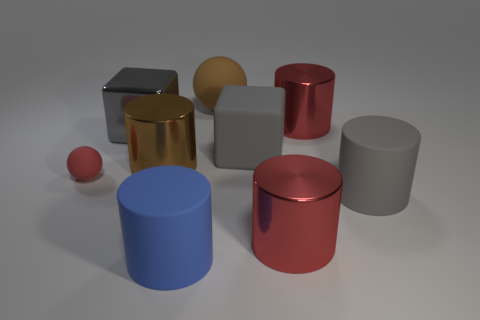Are there any other things that are the same size as the red rubber thing?
Keep it short and to the point. No. There is a object that is to the left of the blue cylinder and in front of the brown cylinder; how big is it?
Your answer should be very brief. Small. There is a large blue object that is the same material as the big ball; what shape is it?
Ensure brevity in your answer.  Cylinder. Is the large blue cylinder made of the same material as the ball that is to the left of the brown ball?
Offer a very short reply. Yes. Is there a blue object that is left of the rubber cylinder that is behind the blue rubber cylinder?
Your response must be concise. Yes. There is another object that is the same shape as the tiny red rubber object; what is it made of?
Provide a succinct answer. Rubber. There is a sphere that is on the left side of the large blue matte cylinder; how many big metallic cylinders are behind it?
Provide a succinct answer. 2. Is there any other thing that has the same color as the tiny rubber thing?
Ensure brevity in your answer.  Yes. How many things are metal things or gray blocks on the right side of the big blue object?
Your answer should be compact. 5. What material is the red thing that is on the right side of the large red object that is in front of the red metallic thing behind the metal cube made of?
Your response must be concise. Metal. 